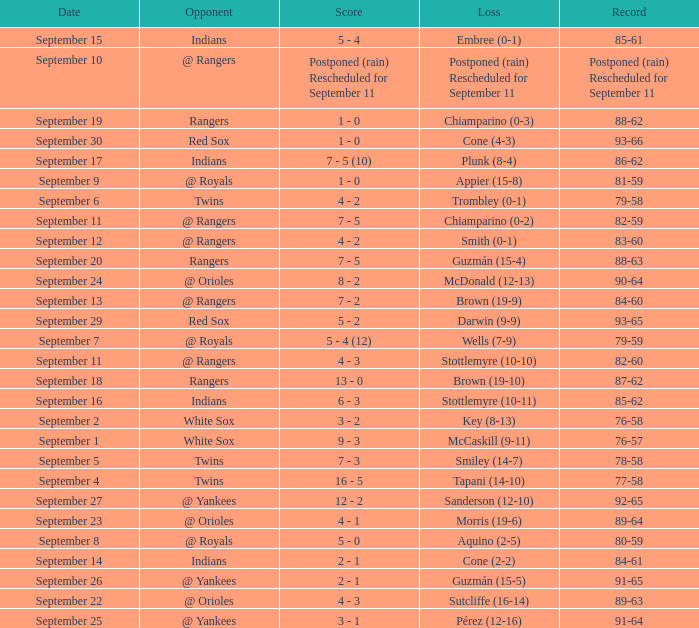What is the score from September 15 that has the Indians as the opponent? 5 - 4. 